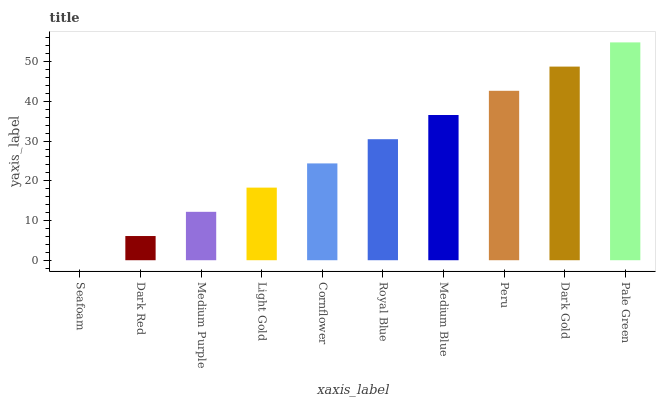Is Seafoam the minimum?
Answer yes or no. Yes. Is Pale Green the maximum?
Answer yes or no. Yes. Is Dark Red the minimum?
Answer yes or no. No. Is Dark Red the maximum?
Answer yes or no. No. Is Dark Red greater than Seafoam?
Answer yes or no. Yes. Is Seafoam less than Dark Red?
Answer yes or no. Yes. Is Seafoam greater than Dark Red?
Answer yes or no. No. Is Dark Red less than Seafoam?
Answer yes or no. No. Is Royal Blue the high median?
Answer yes or no. Yes. Is Cornflower the low median?
Answer yes or no. Yes. Is Peru the high median?
Answer yes or no. No. Is Medium Purple the low median?
Answer yes or no. No. 